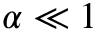Convert formula to latex. <formula><loc_0><loc_0><loc_500><loc_500>\alpha \ll 1</formula> 